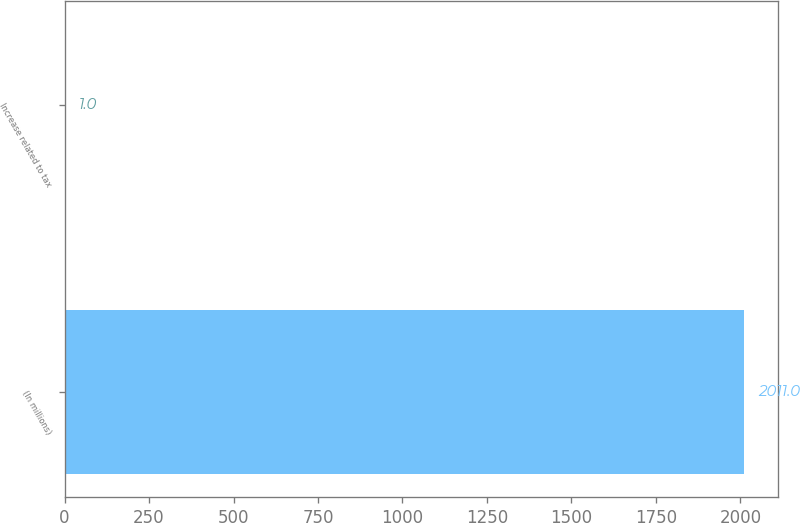<chart> <loc_0><loc_0><loc_500><loc_500><bar_chart><fcel>(In millions)<fcel>Increase related to tax<nl><fcel>2011<fcel>1<nl></chart> 